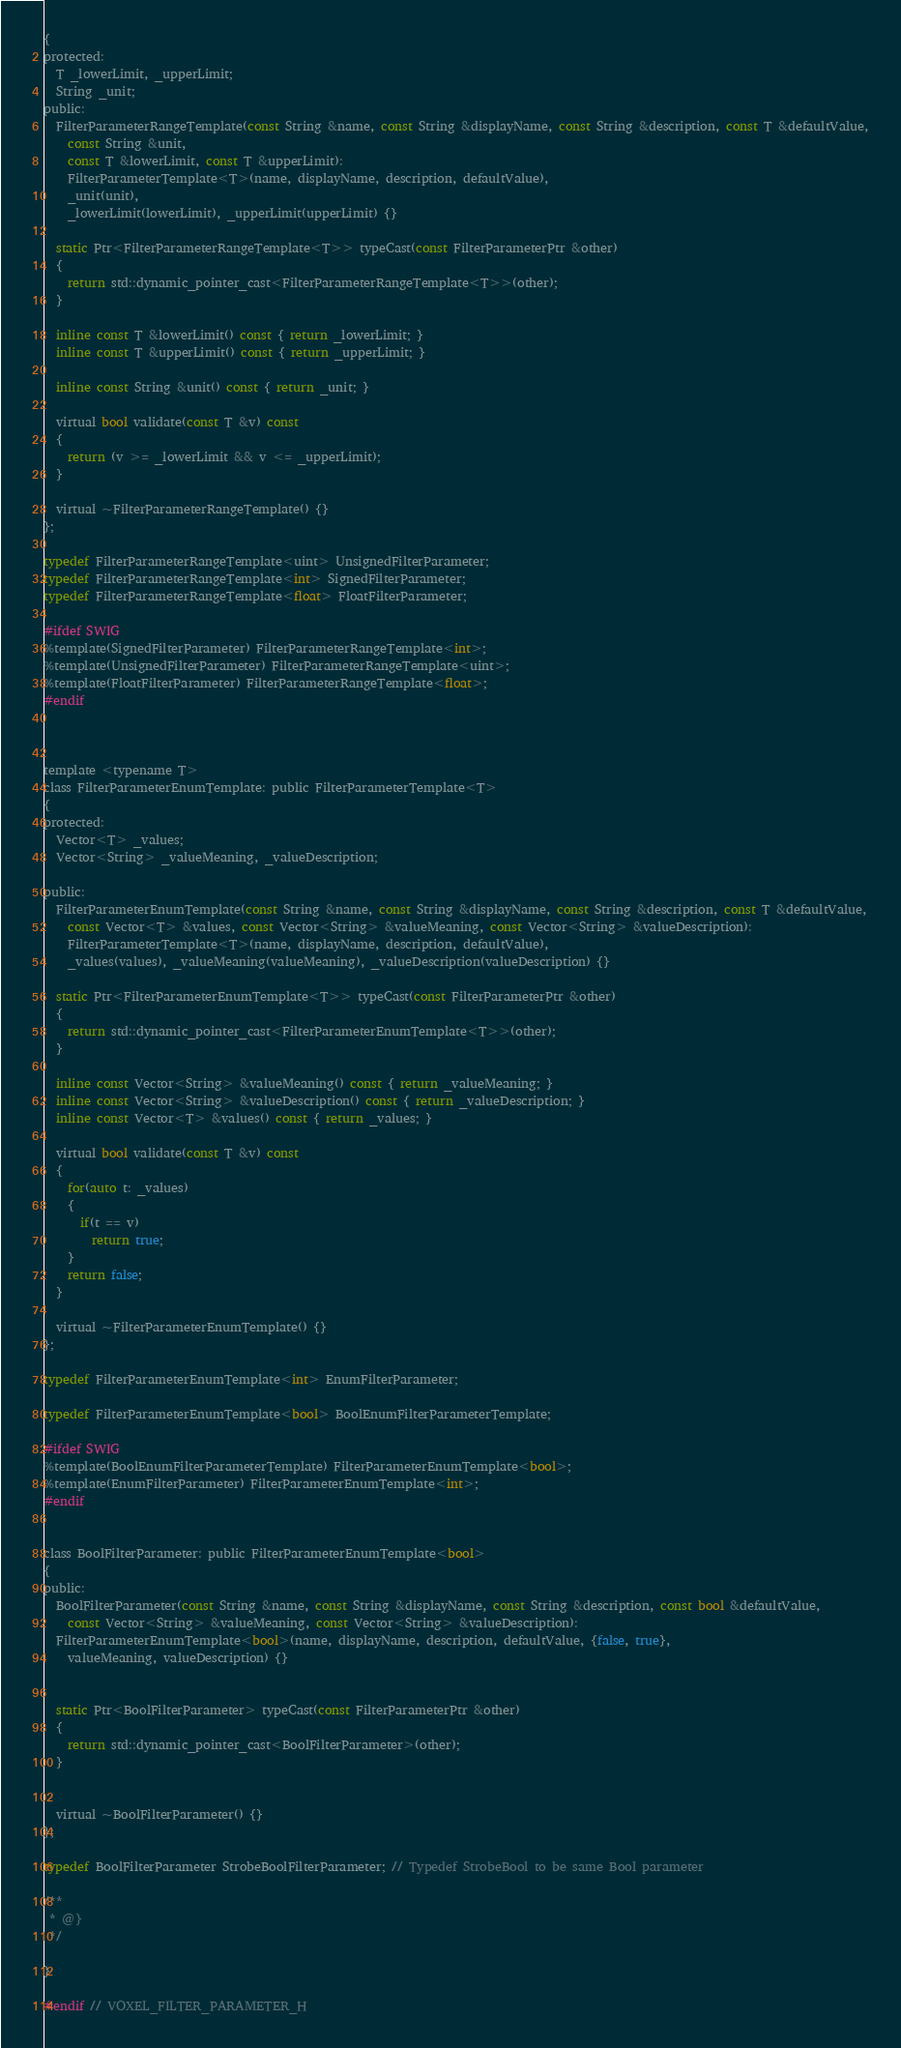<code> <loc_0><loc_0><loc_500><loc_500><_C_>{
protected:
  T _lowerLimit, _upperLimit;
  String _unit;
public:
  FilterParameterRangeTemplate(const String &name, const String &displayName, const String &description, const T &defaultValue,
    const String &unit,
    const T &lowerLimit, const T &upperLimit): 
    FilterParameterTemplate<T>(name, displayName, description, defaultValue), 
    _unit(unit),
    _lowerLimit(lowerLimit), _upperLimit(upperLimit) {}
   
  static Ptr<FilterParameterRangeTemplate<T>> typeCast(const FilterParameterPtr &other)
  {
    return std::dynamic_pointer_cast<FilterParameterRangeTemplate<T>>(other);
  }
   
  inline const T &lowerLimit() const { return _lowerLimit; }
  inline const T &upperLimit() const { return _upperLimit; }
  
  inline const String &unit() const { return _unit; }
  
  virtual bool validate(const T &v) const
  {
    return (v >= _lowerLimit && v <= _upperLimit);
  }
  
  virtual ~FilterParameterRangeTemplate() {}
};

typedef FilterParameterRangeTemplate<uint> UnsignedFilterParameter;
typedef FilterParameterRangeTemplate<int> SignedFilterParameter;
typedef FilterParameterRangeTemplate<float> FloatFilterParameter;

#ifdef SWIG
%template(SignedFilterParameter) FilterParameterRangeTemplate<int>;
%template(UnsignedFilterParameter) FilterParameterRangeTemplate<uint>;
%template(FloatFilterParameter) FilterParameterRangeTemplate<float>;
#endif



template <typename T>
class FilterParameterEnumTemplate: public FilterParameterTemplate<T>
{
protected:
  Vector<T> _values;
  Vector<String> _valueMeaning, _valueDescription;
  
public:
  FilterParameterEnumTemplate(const String &name, const String &displayName, const String &description, const T &defaultValue,
    const Vector<T> &values, const Vector<String> &valueMeaning, const Vector<String> &valueDescription):
    FilterParameterTemplate<T>(name, displayName, description, defaultValue),
    _values(values), _valueMeaning(valueMeaning), _valueDescription(valueDescription) {}
    
  static Ptr<FilterParameterEnumTemplate<T>> typeCast(const FilterParameterPtr &other)
  {
    return std::dynamic_pointer_cast<FilterParameterEnumTemplate<T>>(other);
  }
    
  inline const Vector<String> &valueMeaning() const { return _valueMeaning; }
  inline const Vector<String> &valueDescription() const { return _valueDescription; }
  inline const Vector<T> &values() const { return _values; }
  
  virtual bool validate(const T &v) const
  {
    for(auto t: _values)
    {
      if(t == v)
        return true;
    }
    return false;
  }
  
  virtual ~FilterParameterEnumTemplate() {}
};

typedef FilterParameterEnumTemplate<int> EnumFilterParameter;

typedef FilterParameterEnumTemplate<bool> BoolEnumFilterParameterTemplate;

#ifdef SWIG
%template(BoolEnumFilterParameterTemplate) FilterParameterEnumTemplate<bool>;
%template(EnumFilterParameter) FilterParameterEnumTemplate<int>;
#endif


class BoolFilterParameter: public FilterParameterEnumTemplate<bool>
{
public:
  BoolFilterParameter(const String &name, const String &displayName, const String &description, const bool &defaultValue,
    const Vector<String> &valueMeaning, const Vector<String> &valueDescription):
  FilterParameterEnumTemplate<bool>(name, displayName, description, defaultValue, {false, true},
    valueMeaning, valueDescription) {}
    
    
  static Ptr<BoolFilterParameter> typeCast(const FilterParameterPtr &other)
  {
    return std::dynamic_pointer_cast<BoolFilterParameter>(other);
  }
    
    
  virtual ~BoolFilterParameter() {}
};

typedef BoolFilterParameter StrobeBoolFilterParameter; // Typedef StrobeBool to be same Bool parameter

/**
 * @}
 */

}

#endif // VOXEL_FILTER_PARAMETER_H</code> 